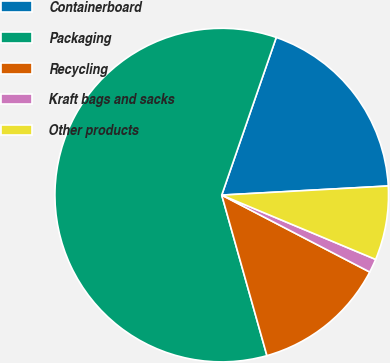Convert chart to OTSL. <chart><loc_0><loc_0><loc_500><loc_500><pie_chart><fcel>Containerboard<fcel>Packaging<fcel>Recycling<fcel>Kraft bags and sacks<fcel>Other products<nl><fcel>18.83%<fcel>59.66%<fcel>13.0%<fcel>1.33%<fcel>7.17%<nl></chart> 